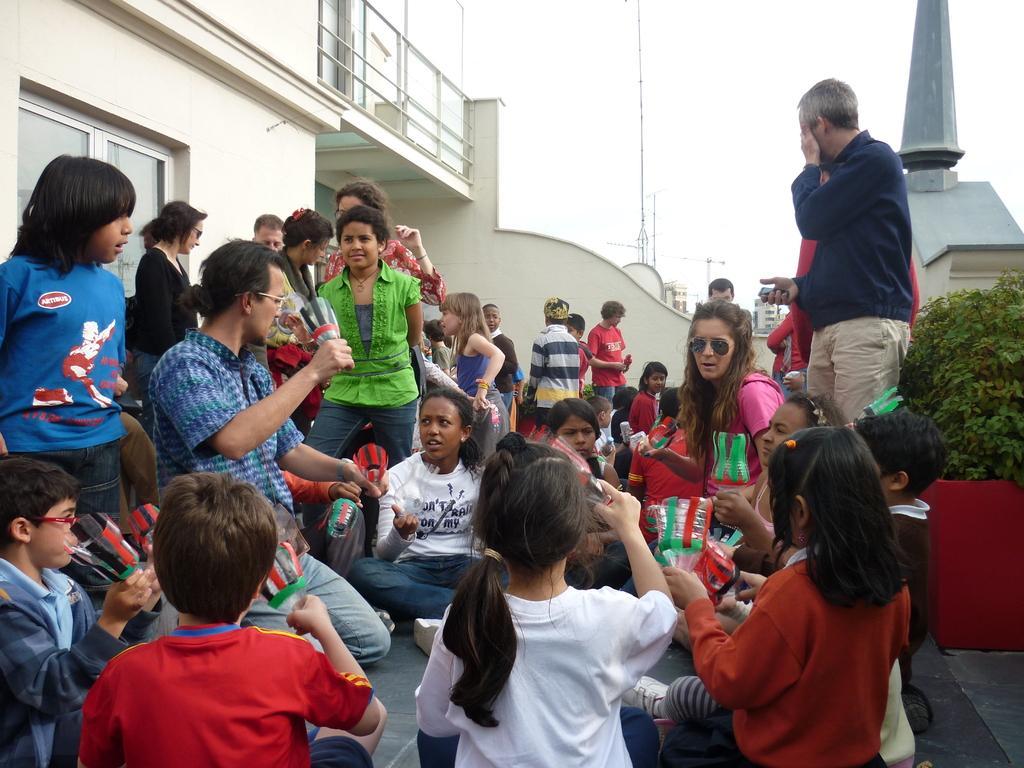In one or two sentences, can you explain what this image depicts? In this image I can see group of people, some are sitting and some are standing, I can also see a glass window. Background I can see plants in green color and I can see the railing, few poles and the sky is in white color. 